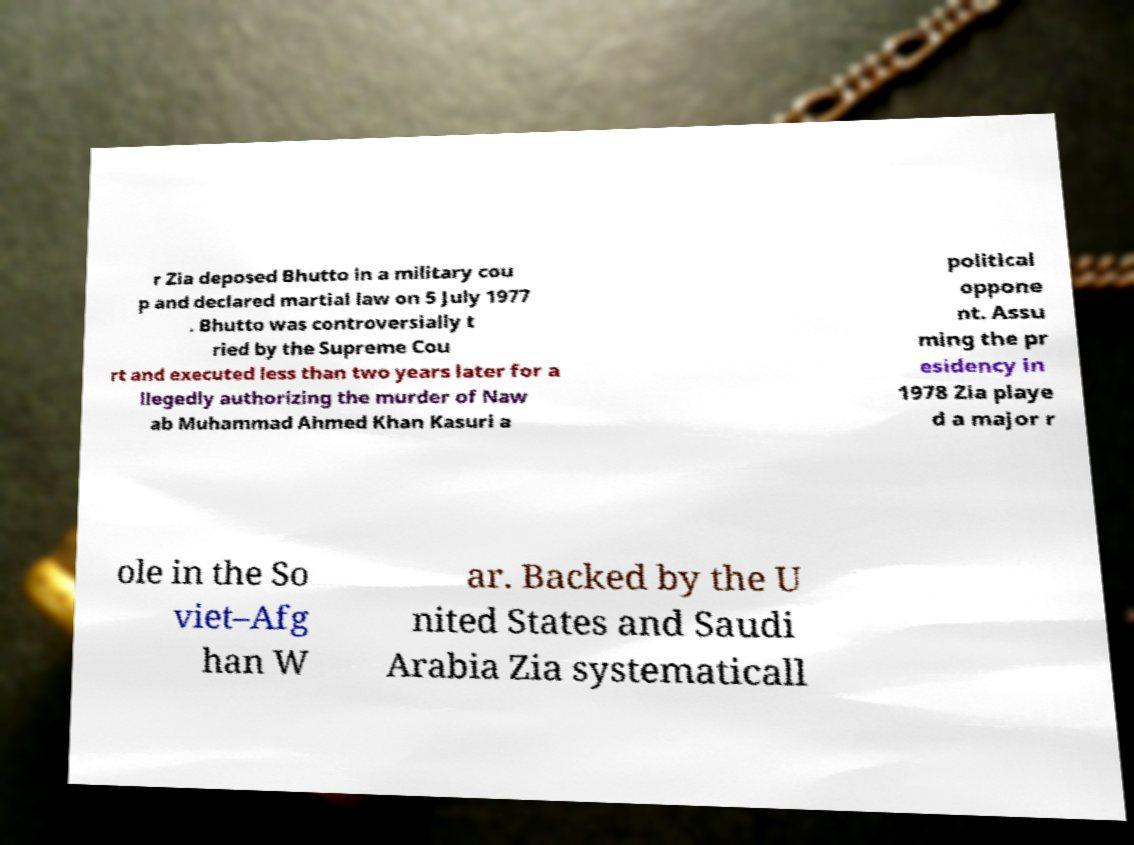Can you read and provide the text displayed in the image?This photo seems to have some interesting text. Can you extract and type it out for me? r Zia deposed Bhutto in a military cou p and declared martial law on 5 July 1977 . Bhutto was controversially t ried by the Supreme Cou rt and executed less than two years later for a llegedly authorizing the murder of Naw ab Muhammad Ahmed Khan Kasuri a political oppone nt. Assu ming the pr esidency in 1978 Zia playe d a major r ole in the So viet–Afg han W ar. Backed by the U nited States and Saudi Arabia Zia systematicall 